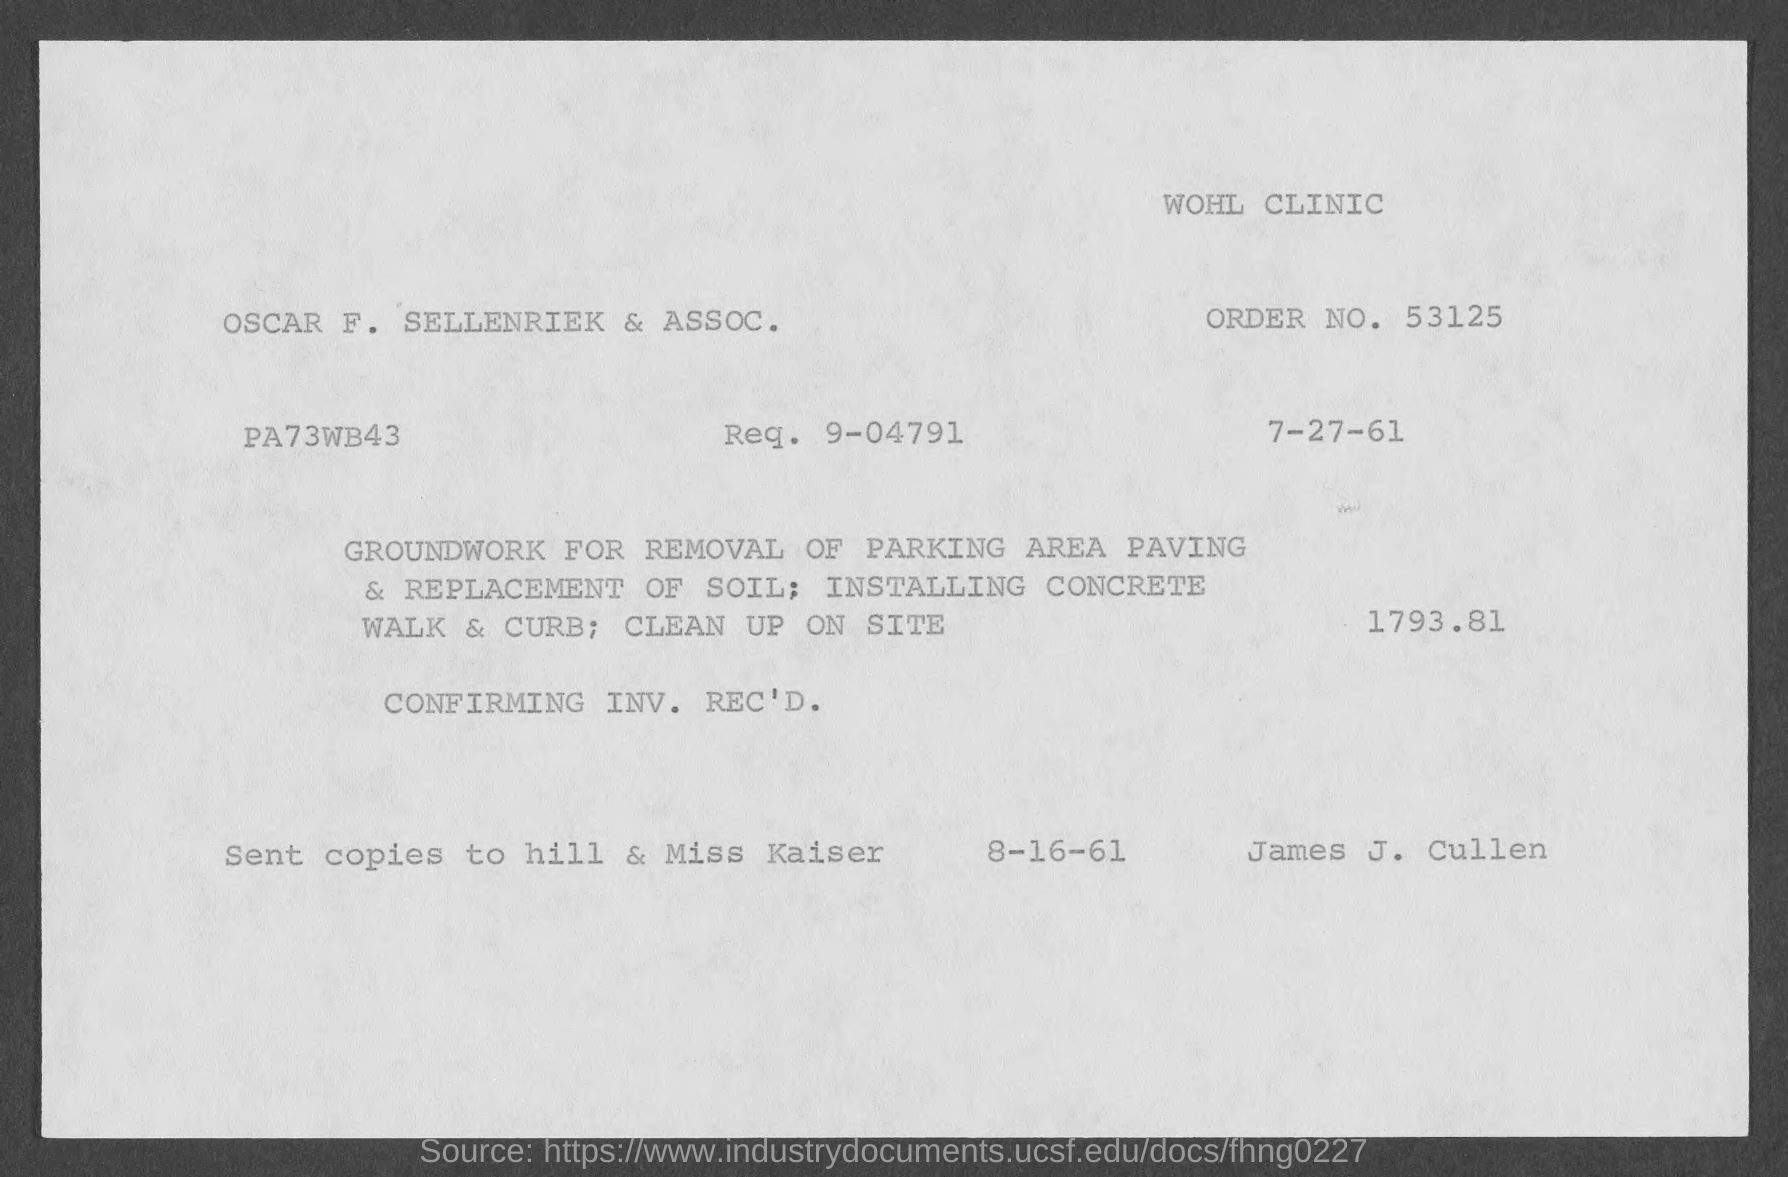What is the order no.?
Make the answer very short. 53125. What is the req. no?
Your answer should be compact. 9-04791. 